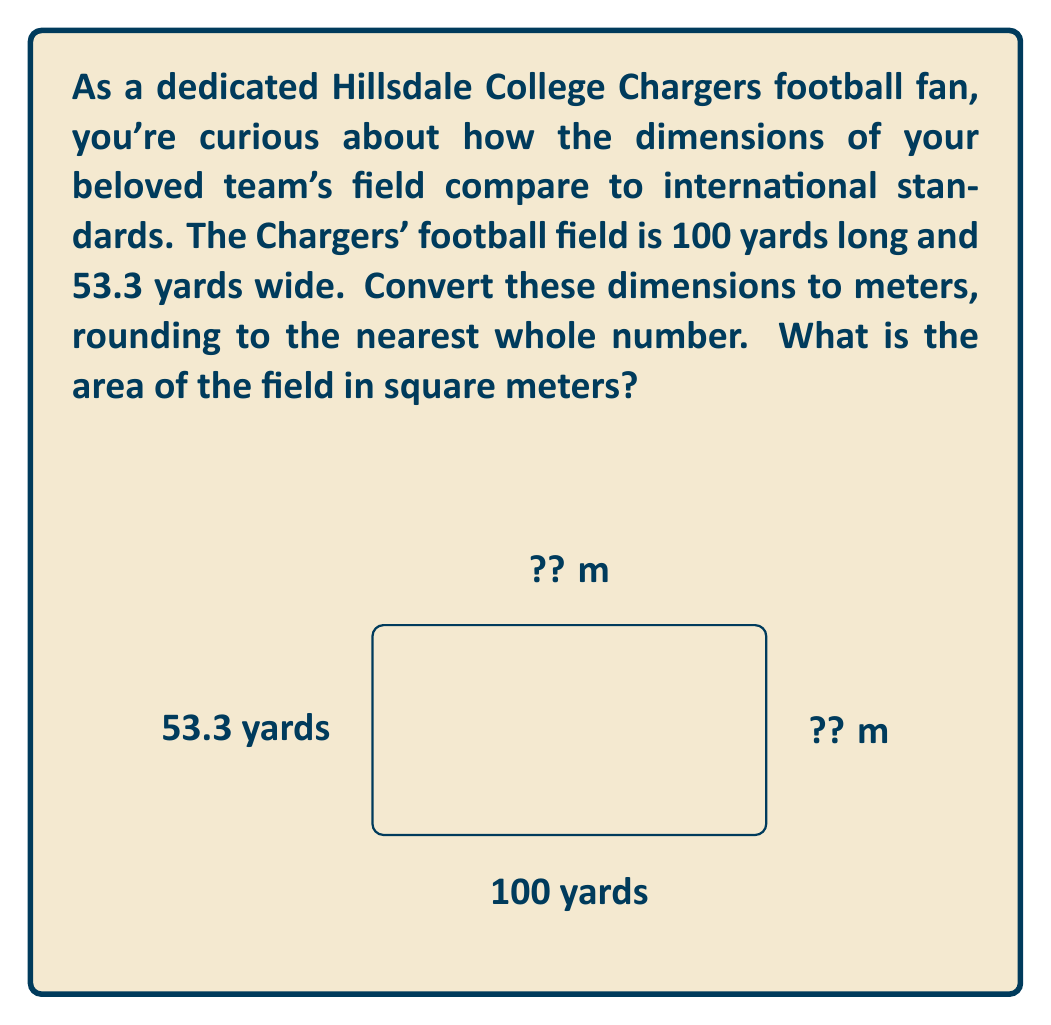What is the answer to this math problem? Let's approach this step-by-step:

1) First, we need to convert yards to meters. 
   1 yard ≈ 0.9144 meters

2) For the length:
   $100 \text{ yards} \times 0.9144 \text{ m/yard} = 91.44 \text{ m}$
   Rounded to the nearest whole number: 91 m

3) For the width:
   $53.3 \text{ yards} \times 0.9144 \text{ m/yard} = 48.73752 \text{ m}$
   Rounded to the nearest whole number: 49 m

4) Now we can calculate the area:
   $\text{Area} = \text{length} \times \text{width}$
   $\text{Area} = 91 \text{ m} \times 49 \text{ m} = 4,459 \text{ m}^2$

Therefore, the Hillsdale College Chargers' football field is approximately 91 m long, 49 m wide, with an area of 4,459 square meters.
Answer: 4,459 m² 